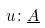<formula> <loc_0><loc_0><loc_500><loc_500>u \colon \underline { A }</formula> 